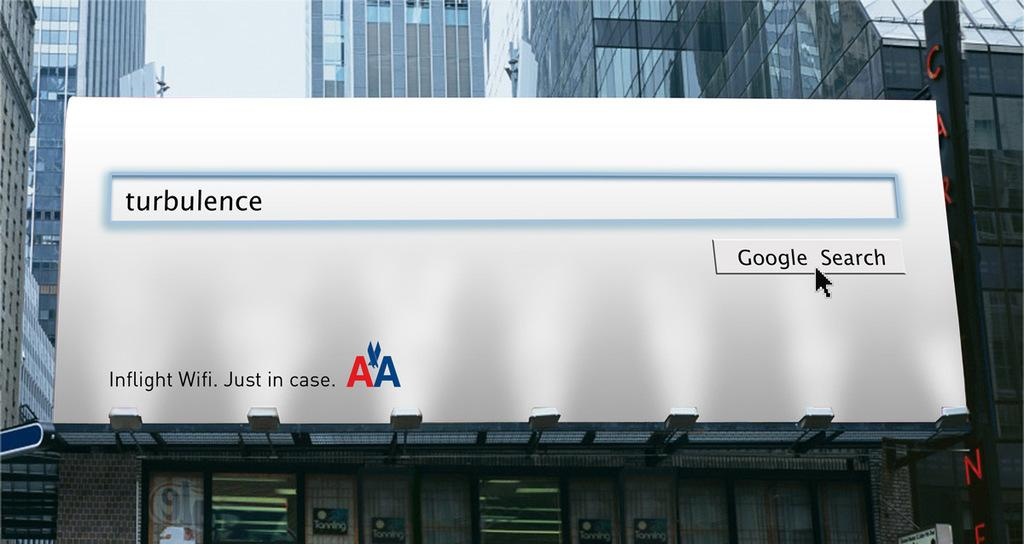<image>
Relay a brief, clear account of the picture shown. A billboard for American Airlines shows a Google search for the word turbulence. 